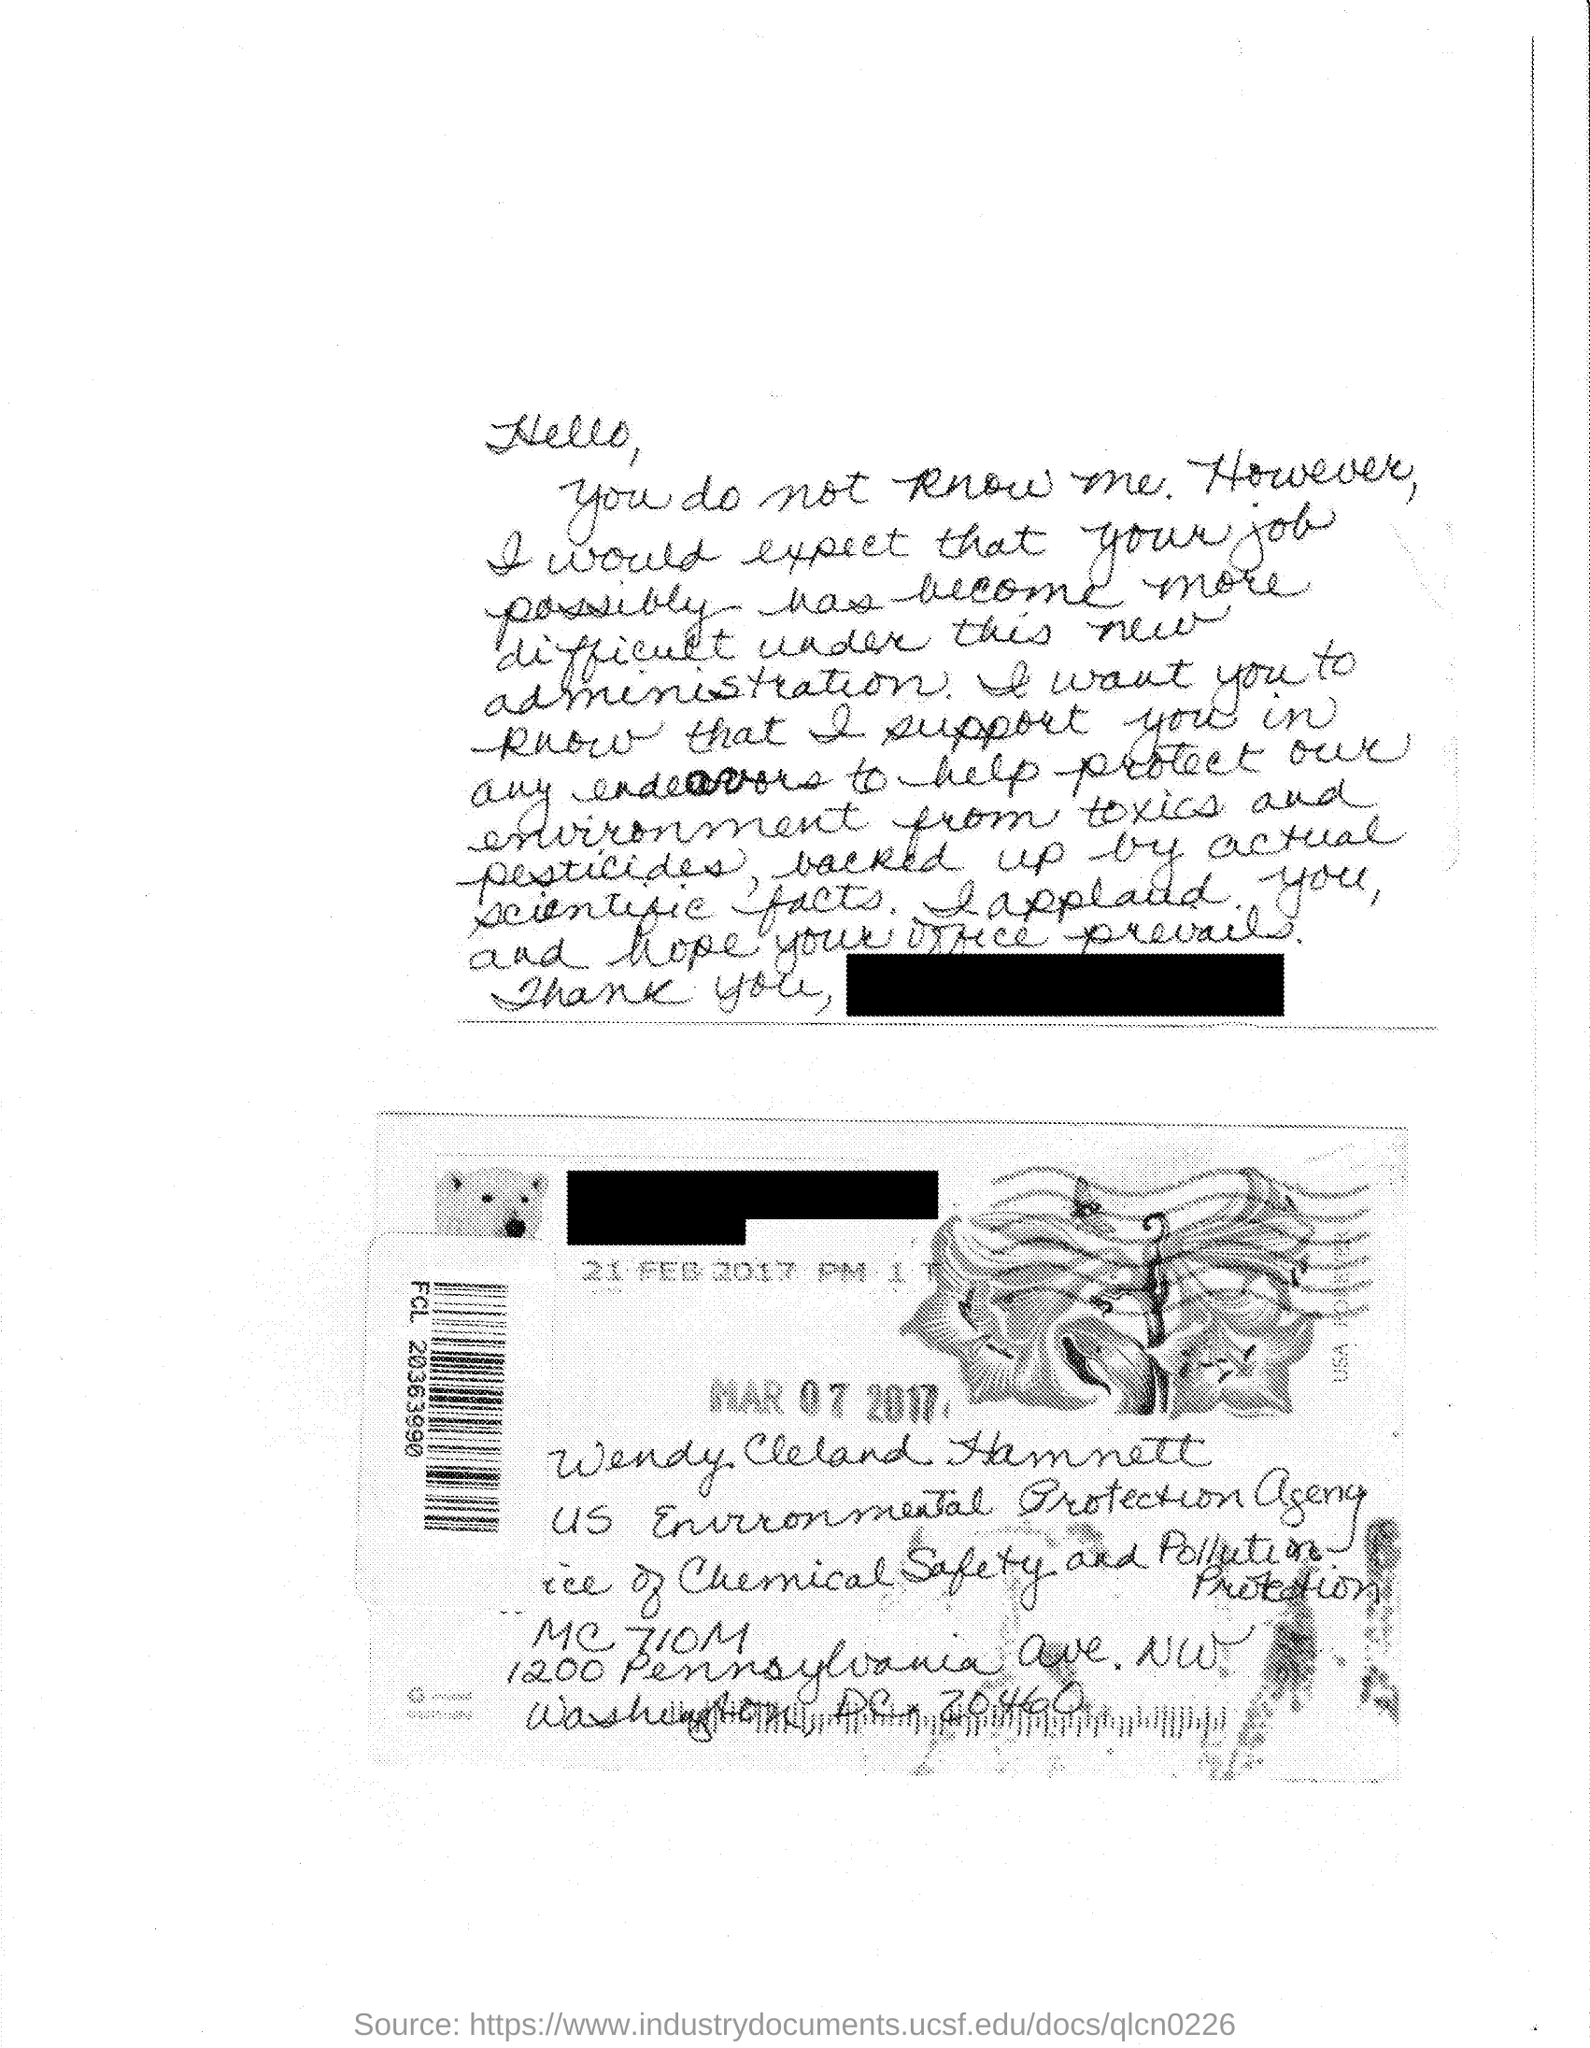Identify some key points in this picture. Wendy Cleland Hamnett is employed by the United States Environmental Protection Agency. The person named in the address is Wendy Cleland Hamnett. 